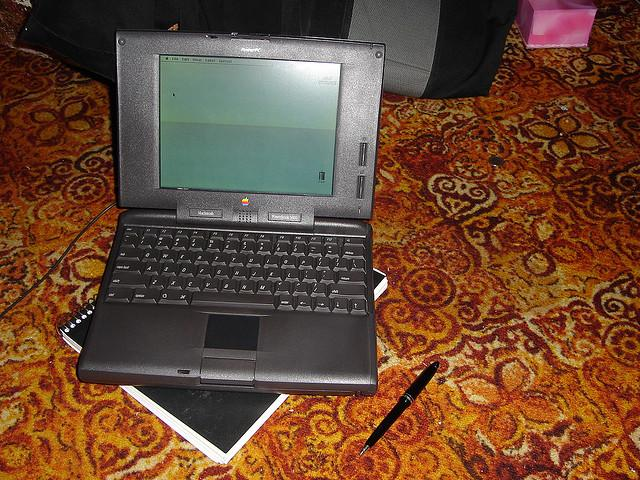What company made the black laptop on the black notebook? apple 